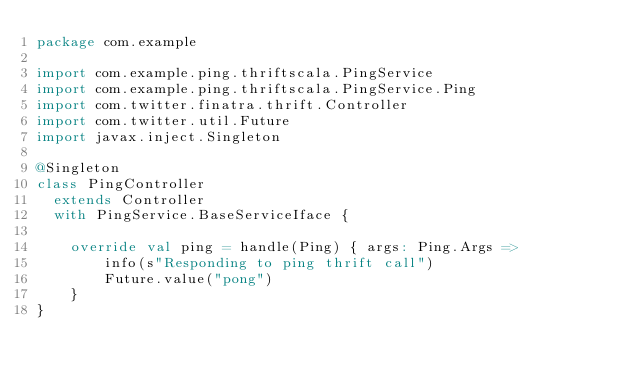Convert code to text. <code><loc_0><loc_0><loc_500><loc_500><_Scala_>package com.example

import com.example.ping.thriftscala.PingService
import com.example.ping.thriftscala.PingService.Ping
import com.twitter.finatra.thrift.Controller
import com.twitter.util.Future
import javax.inject.Singleton

@Singleton
class PingController
  extends Controller
  with PingService.BaseServiceIface {

  	override val ping = handle(Ping) { args: Ping.Args =>
  		info(s"Responding to ping thrift call")
  		Future.value("pong")
  	}
}</code> 